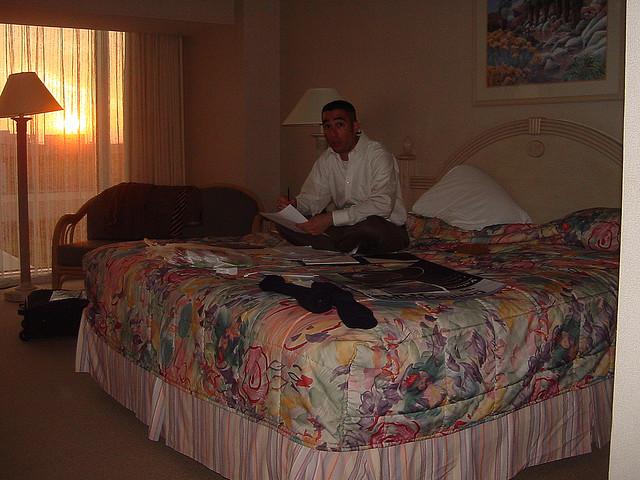Is there a woman in the picture on the wall?
Answer briefly. No. Is this a photo or a painting?
Keep it brief. Photo. What time of day is it based on the weather outside?
Short answer required. Evening. Is this a residence or hotel?
Write a very short answer. Hotel. What kind of room is this called?
Keep it brief. Hotel room. What else is on the bed?
Write a very short answer. Papers. How many people in the picture?
Quick response, please. 1. Is this a child's room or an adult's room?
Keep it brief. Adult. What is the guy staring into?
Write a very short answer. Camera. Is the bed made?
Be succinct. Yes. What style of furniture is the bed?
Give a very brief answer. Bed. What the person on the bed a woman?
Write a very short answer. No. Where is the man in the room?
Short answer required. On bed. 